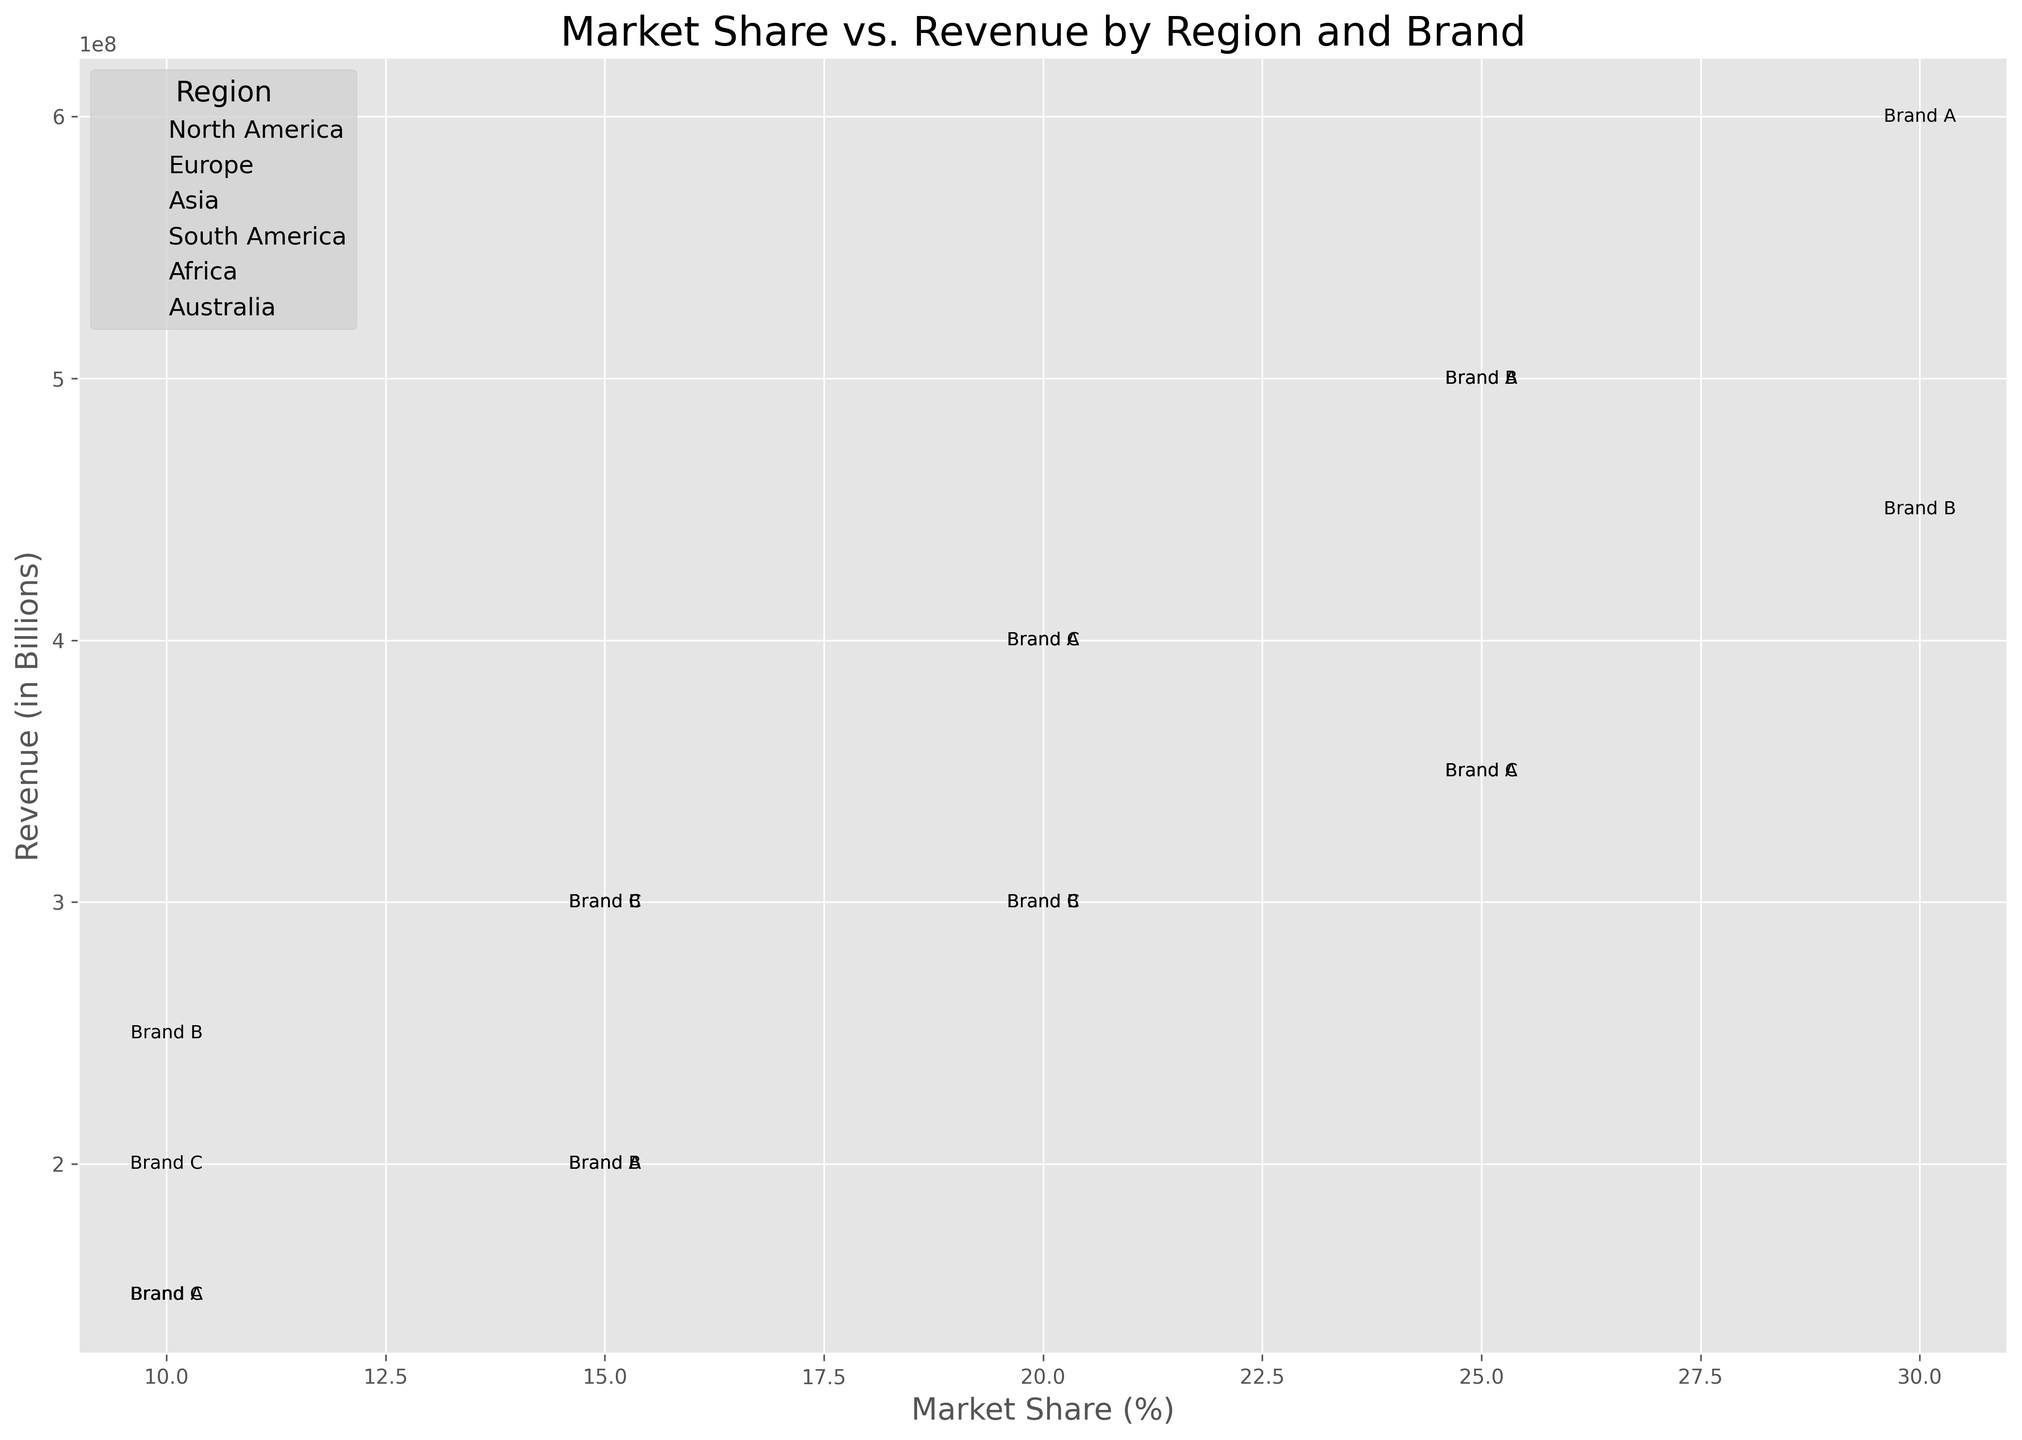What region has the highest revenue for Brand B? To identify the region with the highest revenue for Brand B, visually locate the points labeled as 'B' on the chart and compare their vertical positions (y-coordinates). The highest point will represent the highest revenue. In this case, Asia stands out as the region with the highest revenue for Brand B.
Answer: Asia Which brand has the largest market share in Europe? To find the brand with the largest market share in Europe, look at the horizontal positions (x-coordinates) of the points representing brands in Europe. The brand with the point farthest to the right has the largest market share. Here, Brand A is positioned farthest to the right in the European region.
Answer: Brand A For Brand C, which region has the most number of stores? To determine the region with the most number of stores for Brand C, assess the size of the circles labeled 'C' across different regions. The size of the circle corresponds to the number of stores. Africa has the largest circle among those for Brand C, indicating the most number of stores.
Answer: Africa Compare the market share of Brand A in North America and Asia. Which one is higher? To compare the market share of Brand A between North America and Asia, identify the horizontal positions (x-coordinates) of the points labeled as 'A' in both regions. The point further to the right represents a higher market share. Brand A in Asia is positioned further right than in North America.
Answer: Asia Which region contributes the least revenue for Brand C? To identify the region contributing the least revenue for Brand C, locate the points labeled 'C' and compare their vertical positions (y-coordinates). The point that is lowest represents the least revenue. South America has the lowest point among those for Brand C.
Answer: South America Rank Brand B's market share across all regions from highest to lowest. To rank the market share of Brand B across all regions, examine the horizontal positions (x-coordinates) of points labeled 'B' and arrange them from the farthest right to farthest left: South America (30%), Asia (25%), North America (15%), Europe (10%), Australia (15%), and Africa (20%). Thus, the order is: South America, Asia, Africa, North America, Australia, Europe.
Answer: South America, Asia, Africa, North America, Australia, Europe If we combine the revenue of Brand C in North America and Europe, how does it compare to Brand A's revenue in North America? First, locate the points for Brand C in North America and Europe and add their revenue values (200,000,000 + 300,000,000), which equals 500,000,000. Compare this sum to Brand A's revenue in North America, which is also 500,000,000. The revenues are equal.
Answer: Equal What is the average market share of Brand C across all regions? To calculate the average market share of Brand C, sum the market shares across all regions and then divide by the number of regions (10% + 15% + 20% + 20% + 25% + 10%) = 100% / 6 ≈ 16.67%.
Answer: ~16.67% Which region has the smallest market share for Brand A? Examine the horizontal positions of the points labeled 'A' and identify the one farthest to the left. South America has the smallest market share for Brand A, represented by the leftmost point.
Answer: South America 